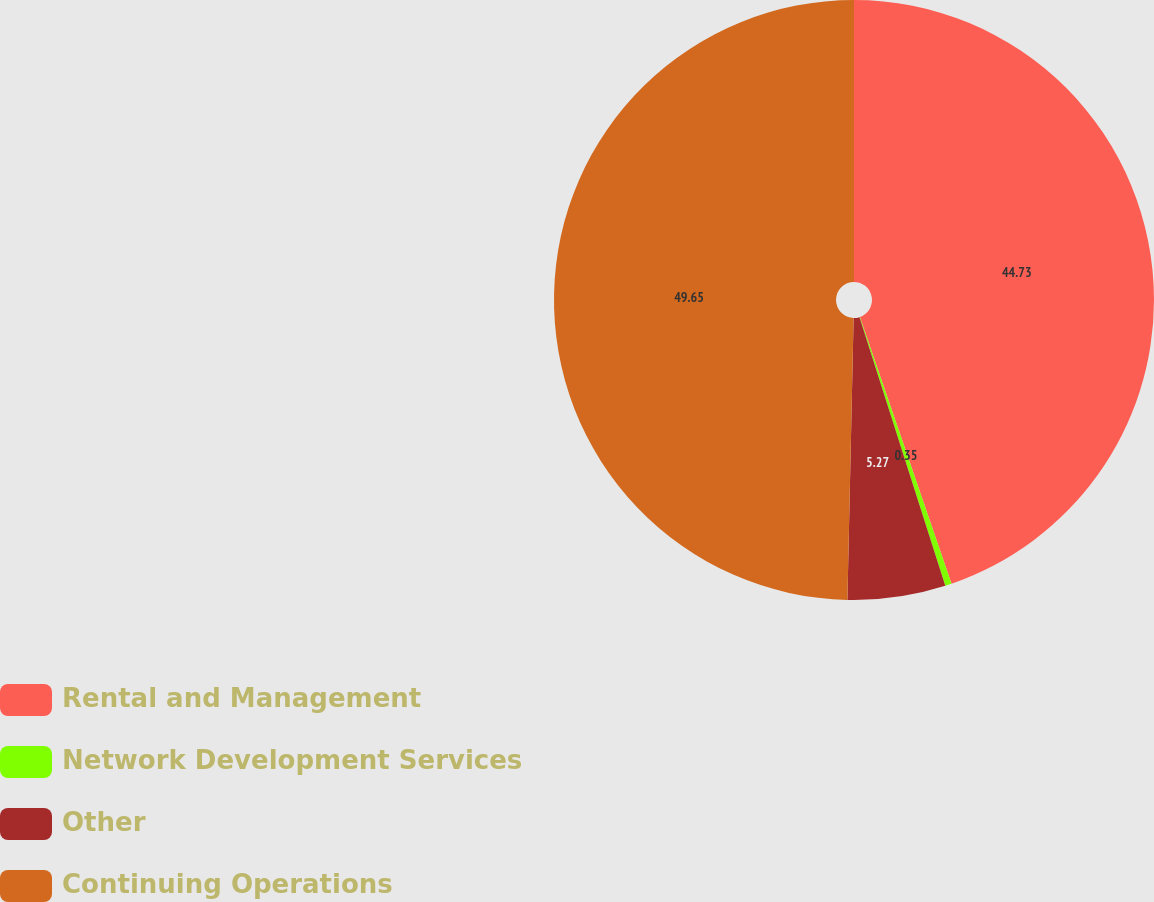<chart> <loc_0><loc_0><loc_500><loc_500><pie_chart><fcel>Rental and Management<fcel>Network Development Services<fcel>Other<fcel>Continuing Operations<nl><fcel>44.73%<fcel>0.35%<fcel>5.27%<fcel>49.65%<nl></chart> 